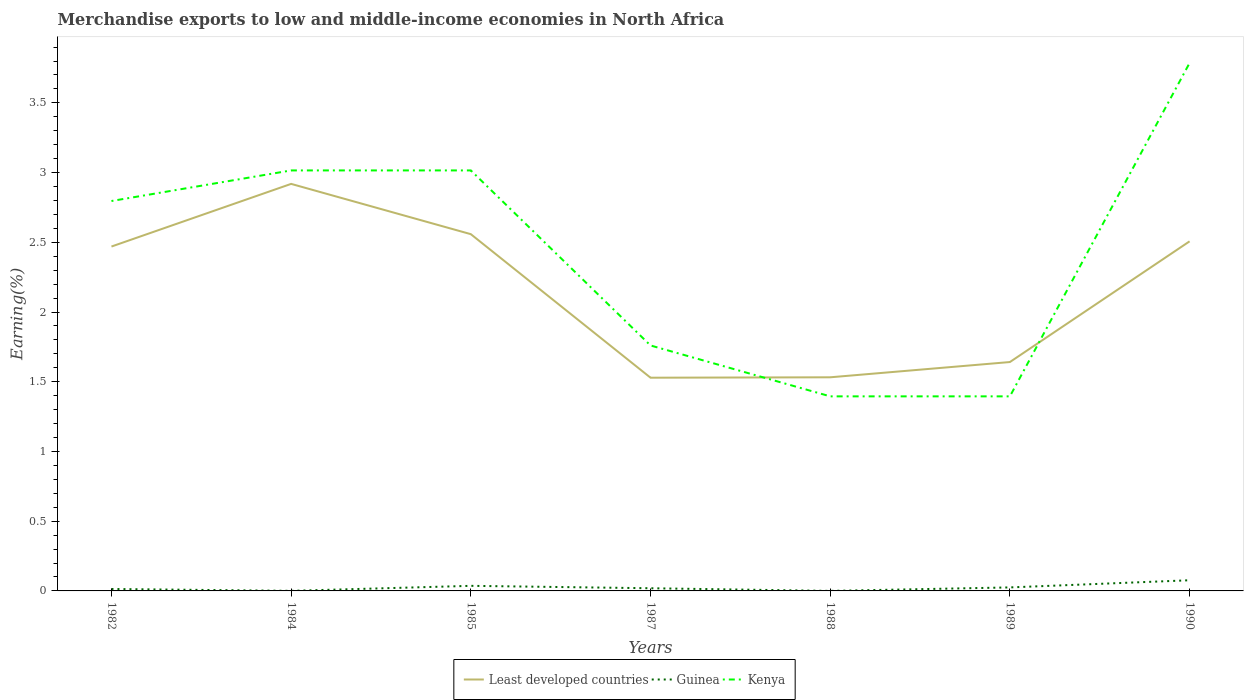How many different coloured lines are there?
Ensure brevity in your answer.  3. Does the line corresponding to Kenya intersect with the line corresponding to Guinea?
Provide a short and direct response. No. Is the number of lines equal to the number of legend labels?
Ensure brevity in your answer.  Yes. Across all years, what is the maximum percentage of amount earned from merchandise exports in Kenya?
Give a very brief answer. 1.4. What is the total percentage of amount earned from merchandise exports in Guinea in the graph?
Make the answer very short. -0.02. What is the difference between the highest and the second highest percentage of amount earned from merchandise exports in Guinea?
Offer a terse response. 0.08. How many lines are there?
Offer a terse response. 3. How many years are there in the graph?
Provide a succinct answer. 7. Does the graph contain grids?
Provide a succinct answer. No. How many legend labels are there?
Your answer should be very brief. 3. What is the title of the graph?
Ensure brevity in your answer.  Merchandise exports to low and middle-income economies in North Africa. What is the label or title of the Y-axis?
Make the answer very short. Earning(%). What is the Earning(%) of Least developed countries in 1982?
Give a very brief answer. 2.47. What is the Earning(%) in Guinea in 1982?
Offer a very short reply. 0.01. What is the Earning(%) in Kenya in 1982?
Keep it short and to the point. 2.8. What is the Earning(%) of Least developed countries in 1984?
Offer a terse response. 2.92. What is the Earning(%) in Guinea in 1984?
Offer a very short reply. 0. What is the Earning(%) of Kenya in 1984?
Ensure brevity in your answer.  3.02. What is the Earning(%) of Least developed countries in 1985?
Offer a terse response. 2.56. What is the Earning(%) of Guinea in 1985?
Your answer should be very brief. 0.04. What is the Earning(%) of Kenya in 1985?
Your response must be concise. 3.02. What is the Earning(%) in Least developed countries in 1987?
Make the answer very short. 1.53. What is the Earning(%) of Guinea in 1987?
Make the answer very short. 0.02. What is the Earning(%) in Kenya in 1987?
Your response must be concise. 1.76. What is the Earning(%) of Least developed countries in 1988?
Offer a very short reply. 1.53. What is the Earning(%) of Guinea in 1988?
Offer a terse response. 0. What is the Earning(%) of Kenya in 1988?
Your answer should be very brief. 1.4. What is the Earning(%) of Least developed countries in 1989?
Your answer should be compact. 1.64. What is the Earning(%) in Guinea in 1989?
Provide a short and direct response. 0.03. What is the Earning(%) of Kenya in 1989?
Provide a short and direct response. 1.4. What is the Earning(%) of Least developed countries in 1990?
Keep it short and to the point. 2.51. What is the Earning(%) in Guinea in 1990?
Offer a very short reply. 0.08. What is the Earning(%) in Kenya in 1990?
Provide a short and direct response. 3.79. Across all years, what is the maximum Earning(%) of Least developed countries?
Offer a very short reply. 2.92. Across all years, what is the maximum Earning(%) of Guinea?
Provide a short and direct response. 0.08. Across all years, what is the maximum Earning(%) in Kenya?
Provide a succinct answer. 3.79. Across all years, what is the minimum Earning(%) of Least developed countries?
Keep it short and to the point. 1.53. Across all years, what is the minimum Earning(%) in Guinea?
Ensure brevity in your answer.  0. Across all years, what is the minimum Earning(%) of Kenya?
Your answer should be compact. 1.4. What is the total Earning(%) of Least developed countries in the graph?
Your answer should be compact. 15.16. What is the total Earning(%) of Guinea in the graph?
Your answer should be very brief. 0.17. What is the total Earning(%) of Kenya in the graph?
Provide a short and direct response. 17.16. What is the difference between the Earning(%) of Least developed countries in 1982 and that in 1984?
Provide a succinct answer. -0.45. What is the difference between the Earning(%) of Guinea in 1982 and that in 1984?
Ensure brevity in your answer.  0.01. What is the difference between the Earning(%) in Kenya in 1982 and that in 1984?
Provide a short and direct response. -0.22. What is the difference between the Earning(%) in Least developed countries in 1982 and that in 1985?
Keep it short and to the point. -0.09. What is the difference between the Earning(%) in Guinea in 1982 and that in 1985?
Offer a terse response. -0.02. What is the difference between the Earning(%) in Kenya in 1982 and that in 1985?
Keep it short and to the point. -0.22. What is the difference between the Earning(%) of Least developed countries in 1982 and that in 1987?
Your answer should be very brief. 0.94. What is the difference between the Earning(%) of Guinea in 1982 and that in 1987?
Offer a terse response. -0.01. What is the difference between the Earning(%) in Kenya in 1982 and that in 1987?
Keep it short and to the point. 1.04. What is the difference between the Earning(%) in Least developed countries in 1982 and that in 1988?
Give a very brief answer. 0.94. What is the difference between the Earning(%) in Guinea in 1982 and that in 1988?
Your response must be concise. 0.01. What is the difference between the Earning(%) in Kenya in 1982 and that in 1988?
Your answer should be compact. 1.4. What is the difference between the Earning(%) in Least developed countries in 1982 and that in 1989?
Ensure brevity in your answer.  0.83. What is the difference between the Earning(%) of Guinea in 1982 and that in 1989?
Ensure brevity in your answer.  -0.01. What is the difference between the Earning(%) in Kenya in 1982 and that in 1989?
Provide a succinct answer. 1.4. What is the difference between the Earning(%) of Least developed countries in 1982 and that in 1990?
Keep it short and to the point. -0.04. What is the difference between the Earning(%) in Guinea in 1982 and that in 1990?
Provide a succinct answer. -0.06. What is the difference between the Earning(%) in Kenya in 1982 and that in 1990?
Make the answer very short. -0.99. What is the difference between the Earning(%) of Least developed countries in 1984 and that in 1985?
Keep it short and to the point. 0.36. What is the difference between the Earning(%) of Guinea in 1984 and that in 1985?
Ensure brevity in your answer.  -0.04. What is the difference between the Earning(%) of Kenya in 1984 and that in 1985?
Your answer should be compact. 0. What is the difference between the Earning(%) in Least developed countries in 1984 and that in 1987?
Your answer should be compact. 1.39. What is the difference between the Earning(%) of Guinea in 1984 and that in 1987?
Your response must be concise. -0.02. What is the difference between the Earning(%) in Kenya in 1984 and that in 1987?
Your answer should be compact. 1.26. What is the difference between the Earning(%) in Least developed countries in 1984 and that in 1988?
Ensure brevity in your answer.  1.39. What is the difference between the Earning(%) in Guinea in 1984 and that in 1988?
Keep it short and to the point. 0. What is the difference between the Earning(%) of Kenya in 1984 and that in 1988?
Your response must be concise. 1.62. What is the difference between the Earning(%) of Least developed countries in 1984 and that in 1989?
Offer a very short reply. 1.28. What is the difference between the Earning(%) in Guinea in 1984 and that in 1989?
Your answer should be very brief. -0.02. What is the difference between the Earning(%) of Kenya in 1984 and that in 1989?
Offer a terse response. 1.62. What is the difference between the Earning(%) in Least developed countries in 1984 and that in 1990?
Give a very brief answer. 0.41. What is the difference between the Earning(%) in Guinea in 1984 and that in 1990?
Offer a terse response. -0.08. What is the difference between the Earning(%) in Kenya in 1984 and that in 1990?
Give a very brief answer. -0.77. What is the difference between the Earning(%) of Least developed countries in 1985 and that in 1987?
Your answer should be very brief. 1.03. What is the difference between the Earning(%) in Guinea in 1985 and that in 1987?
Your response must be concise. 0.02. What is the difference between the Earning(%) in Kenya in 1985 and that in 1987?
Your answer should be very brief. 1.26. What is the difference between the Earning(%) in Least developed countries in 1985 and that in 1988?
Your answer should be compact. 1.03. What is the difference between the Earning(%) of Guinea in 1985 and that in 1988?
Give a very brief answer. 0.04. What is the difference between the Earning(%) in Kenya in 1985 and that in 1988?
Offer a very short reply. 1.62. What is the difference between the Earning(%) in Least developed countries in 1985 and that in 1989?
Your answer should be very brief. 0.92. What is the difference between the Earning(%) of Guinea in 1985 and that in 1989?
Keep it short and to the point. 0.01. What is the difference between the Earning(%) in Kenya in 1985 and that in 1989?
Give a very brief answer. 1.62. What is the difference between the Earning(%) in Least developed countries in 1985 and that in 1990?
Offer a very short reply. 0.05. What is the difference between the Earning(%) of Guinea in 1985 and that in 1990?
Give a very brief answer. -0.04. What is the difference between the Earning(%) of Kenya in 1985 and that in 1990?
Your response must be concise. -0.77. What is the difference between the Earning(%) of Least developed countries in 1987 and that in 1988?
Offer a terse response. -0. What is the difference between the Earning(%) in Guinea in 1987 and that in 1988?
Make the answer very short. 0.02. What is the difference between the Earning(%) of Kenya in 1987 and that in 1988?
Keep it short and to the point. 0.36. What is the difference between the Earning(%) in Least developed countries in 1987 and that in 1989?
Give a very brief answer. -0.11. What is the difference between the Earning(%) in Guinea in 1987 and that in 1989?
Give a very brief answer. -0.01. What is the difference between the Earning(%) of Kenya in 1987 and that in 1989?
Give a very brief answer. 0.36. What is the difference between the Earning(%) of Least developed countries in 1987 and that in 1990?
Make the answer very short. -0.98. What is the difference between the Earning(%) in Guinea in 1987 and that in 1990?
Offer a very short reply. -0.06. What is the difference between the Earning(%) of Kenya in 1987 and that in 1990?
Your answer should be compact. -2.03. What is the difference between the Earning(%) of Least developed countries in 1988 and that in 1989?
Offer a very short reply. -0.11. What is the difference between the Earning(%) in Guinea in 1988 and that in 1989?
Provide a short and direct response. -0.02. What is the difference between the Earning(%) of Least developed countries in 1988 and that in 1990?
Provide a succinct answer. -0.97. What is the difference between the Earning(%) in Guinea in 1988 and that in 1990?
Offer a very short reply. -0.08. What is the difference between the Earning(%) of Kenya in 1988 and that in 1990?
Your answer should be compact. -2.39. What is the difference between the Earning(%) in Least developed countries in 1989 and that in 1990?
Your answer should be compact. -0.87. What is the difference between the Earning(%) of Guinea in 1989 and that in 1990?
Provide a short and direct response. -0.05. What is the difference between the Earning(%) of Kenya in 1989 and that in 1990?
Your answer should be very brief. -2.39. What is the difference between the Earning(%) in Least developed countries in 1982 and the Earning(%) in Guinea in 1984?
Offer a very short reply. 2.47. What is the difference between the Earning(%) in Least developed countries in 1982 and the Earning(%) in Kenya in 1984?
Make the answer very short. -0.55. What is the difference between the Earning(%) of Guinea in 1982 and the Earning(%) of Kenya in 1984?
Your answer should be very brief. -3. What is the difference between the Earning(%) in Least developed countries in 1982 and the Earning(%) in Guinea in 1985?
Keep it short and to the point. 2.43. What is the difference between the Earning(%) in Least developed countries in 1982 and the Earning(%) in Kenya in 1985?
Ensure brevity in your answer.  -0.55. What is the difference between the Earning(%) of Guinea in 1982 and the Earning(%) of Kenya in 1985?
Make the answer very short. -3. What is the difference between the Earning(%) in Least developed countries in 1982 and the Earning(%) in Guinea in 1987?
Offer a very short reply. 2.45. What is the difference between the Earning(%) of Least developed countries in 1982 and the Earning(%) of Kenya in 1987?
Your response must be concise. 0.71. What is the difference between the Earning(%) of Guinea in 1982 and the Earning(%) of Kenya in 1987?
Your answer should be very brief. -1.75. What is the difference between the Earning(%) of Least developed countries in 1982 and the Earning(%) of Guinea in 1988?
Offer a terse response. 2.47. What is the difference between the Earning(%) of Least developed countries in 1982 and the Earning(%) of Kenya in 1988?
Keep it short and to the point. 1.07. What is the difference between the Earning(%) in Guinea in 1982 and the Earning(%) in Kenya in 1988?
Offer a very short reply. -1.38. What is the difference between the Earning(%) in Least developed countries in 1982 and the Earning(%) in Guinea in 1989?
Offer a very short reply. 2.44. What is the difference between the Earning(%) in Least developed countries in 1982 and the Earning(%) in Kenya in 1989?
Ensure brevity in your answer.  1.07. What is the difference between the Earning(%) of Guinea in 1982 and the Earning(%) of Kenya in 1989?
Offer a very short reply. -1.38. What is the difference between the Earning(%) of Least developed countries in 1982 and the Earning(%) of Guinea in 1990?
Keep it short and to the point. 2.39. What is the difference between the Earning(%) in Least developed countries in 1982 and the Earning(%) in Kenya in 1990?
Make the answer very short. -1.32. What is the difference between the Earning(%) of Guinea in 1982 and the Earning(%) of Kenya in 1990?
Provide a short and direct response. -3.77. What is the difference between the Earning(%) of Least developed countries in 1984 and the Earning(%) of Guinea in 1985?
Provide a succinct answer. 2.88. What is the difference between the Earning(%) of Least developed countries in 1984 and the Earning(%) of Kenya in 1985?
Your response must be concise. -0.1. What is the difference between the Earning(%) of Guinea in 1984 and the Earning(%) of Kenya in 1985?
Your response must be concise. -3.01. What is the difference between the Earning(%) in Least developed countries in 1984 and the Earning(%) in Guinea in 1987?
Provide a short and direct response. 2.9. What is the difference between the Earning(%) of Least developed countries in 1984 and the Earning(%) of Kenya in 1987?
Keep it short and to the point. 1.16. What is the difference between the Earning(%) in Guinea in 1984 and the Earning(%) in Kenya in 1987?
Offer a very short reply. -1.76. What is the difference between the Earning(%) in Least developed countries in 1984 and the Earning(%) in Guinea in 1988?
Offer a very short reply. 2.92. What is the difference between the Earning(%) of Least developed countries in 1984 and the Earning(%) of Kenya in 1988?
Your answer should be very brief. 1.52. What is the difference between the Earning(%) in Guinea in 1984 and the Earning(%) in Kenya in 1988?
Give a very brief answer. -1.39. What is the difference between the Earning(%) of Least developed countries in 1984 and the Earning(%) of Guinea in 1989?
Provide a succinct answer. 2.89. What is the difference between the Earning(%) in Least developed countries in 1984 and the Earning(%) in Kenya in 1989?
Your answer should be very brief. 1.52. What is the difference between the Earning(%) in Guinea in 1984 and the Earning(%) in Kenya in 1989?
Provide a succinct answer. -1.39. What is the difference between the Earning(%) in Least developed countries in 1984 and the Earning(%) in Guinea in 1990?
Ensure brevity in your answer.  2.84. What is the difference between the Earning(%) in Least developed countries in 1984 and the Earning(%) in Kenya in 1990?
Your response must be concise. -0.87. What is the difference between the Earning(%) of Guinea in 1984 and the Earning(%) of Kenya in 1990?
Make the answer very short. -3.79. What is the difference between the Earning(%) of Least developed countries in 1985 and the Earning(%) of Guinea in 1987?
Your answer should be very brief. 2.54. What is the difference between the Earning(%) in Least developed countries in 1985 and the Earning(%) in Kenya in 1987?
Ensure brevity in your answer.  0.8. What is the difference between the Earning(%) in Guinea in 1985 and the Earning(%) in Kenya in 1987?
Offer a terse response. -1.72. What is the difference between the Earning(%) of Least developed countries in 1985 and the Earning(%) of Guinea in 1988?
Keep it short and to the point. 2.56. What is the difference between the Earning(%) of Least developed countries in 1985 and the Earning(%) of Kenya in 1988?
Ensure brevity in your answer.  1.16. What is the difference between the Earning(%) in Guinea in 1985 and the Earning(%) in Kenya in 1988?
Provide a succinct answer. -1.36. What is the difference between the Earning(%) in Least developed countries in 1985 and the Earning(%) in Guinea in 1989?
Your answer should be very brief. 2.53. What is the difference between the Earning(%) in Least developed countries in 1985 and the Earning(%) in Kenya in 1989?
Give a very brief answer. 1.16. What is the difference between the Earning(%) of Guinea in 1985 and the Earning(%) of Kenya in 1989?
Provide a short and direct response. -1.36. What is the difference between the Earning(%) in Least developed countries in 1985 and the Earning(%) in Guinea in 1990?
Make the answer very short. 2.48. What is the difference between the Earning(%) of Least developed countries in 1985 and the Earning(%) of Kenya in 1990?
Your response must be concise. -1.23. What is the difference between the Earning(%) in Guinea in 1985 and the Earning(%) in Kenya in 1990?
Your response must be concise. -3.75. What is the difference between the Earning(%) in Least developed countries in 1987 and the Earning(%) in Guinea in 1988?
Your answer should be compact. 1.53. What is the difference between the Earning(%) of Least developed countries in 1987 and the Earning(%) of Kenya in 1988?
Your answer should be compact. 0.13. What is the difference between the Earning(%) of Guinea in 1987 and the Earning(%) of Kenya in 1988?
Offer a very short reply. -1.38. What is the difference between the Earning(%) in Least developed countries in 1987 and the Earning(%) in Guinea in 1989?
Make the answer very short. 1.5. What is the difference between the Earning(%) of Least developed countries in 1987 and the Earning(%) of Kenya in 1989?
Provide a short and direct response. 0.13. What is the difference between the Earning(%) in Guinea in 1987 and the Earning(%) in Kenya in 1989?
Your answer should be compact. -1.38. What is the difference between the Earning(%) of Least developed countries in 1987 and the Earning(%) of Guinea in 1990?
Your answer should be compact. 1.45. What is the difference between the Earning(%) of Least developed countries in 1987 and the Earning(%) of Kenya in 1990?
Offer a terse response. -2.26. What is the difference between the Earning(%) in Guinea in 1987 and the Earning(%) in Kenya in 1990?
Keep it short and to the point. -3.77. What is the difference between the Earning(%) in Least developed countries in 1988 and the Earning(%) in Guinea in 1989?
Offer a very short reply. 1.51. What is the difference between the Earning(%) of Least developed countries in 1988 and the Earning(%) of Kenya in 1989?
Ensure brevity in your answer.  0.14. What is the difference between the Earning(%) in Guinea in 1988 and the Earning(%) in Kenya in 1989?
Your answer should be compact. -1.4. What is the difference between the Earning(%) in Least developed countries in 1988 and the Earning(%) in Guinea in 1990?
Offer a very short reply. 1.46. What is the difference between the Earning(%) in Least developed countries in 1988 and the Earning(%) in Kenya in 1990?
Provide a succinct answer. -2.25. What is the difference between the Earning(%) in Guinea in 1988 and the Earning(%) in Kenya in 1990?
Ensure brevity in your answer.  -3.79. What is the difference between the Earning(%) in Least developed countries in 1989 and the Earning(%) in Guinea in 1990?
Provide a short and direct response. 1.56. What is the difference between the Earning(%) of Least developed countries in 1989 and the Earning(%) of Kenya in 1990?
Provide a short and direct response. -2.14. What is the difference between the Earning(%) of Guinea in 1989 and the Earning(%) of Kenya in 1990?
Make the answer very short. -3.76. What is the average Earning(%) in Least developed countries per year?
Make the answer very short. 2.17. What is the average Earning(%) of Guinea per year?
Offer a very short reply. 0.02. What is the average Earning(%) in Kenya per year?
Your answer should be compact. 2.45. In the year 1982, what is the difference between the Earning(%) in Least developed countries and Earning(%) in Guinea?
Offer a terse response. 2.46. In the year 1982, what is the difference between the Earning(%) of Least developed countries and Earning(%) of Kenya?
Make the answer very short. -0.33. In the year 1982, what is the difference between the Earning(%) of Guinea and Earning(%) of Kenya?
Ensure brevity in your answer.  -2.78. In the year 1984, what is the difference between the Earning(%) in Least developed countries and Earning(%) in Guinea?
Make the answer very short. 2.92. In the year 1984, what is the difference between the Earning(%) in Least developed countries and Earning(%) in Kenya?
Your answer should be very brief. -0.1. In the year 1984, what is the difference between the Earning(%) of Guinea and Earning(%) of Kenya?
Offer a very short reply. -3.01. In the year 1985, what is the difference between the Earning(%) of Least developed countries and Earning(%) of Guinea?
Your response must be concise. 2.52. In the year 1985, what is the difference between the Earning(%) of Least developed countries and Earning(%) of Kenya?
Give a very brief answer. -0.46. In the year 1985, what is the difference between the Earning(%) in Guinea and Earning(%) in Kenya?
Your answer should be compact. -2.98. In the year 1987, what is the difference between the Earning(%) in Least developed countries and Earning(%) in Guinea?
Give a very brief answer. 1.51. In the year 1987, what is the difference between the Earning(%) in Least developed countries and Earning(%) in Kenya?
Provide a succinct answer. -0.23. In the year 1987, what is the difference between the Earning(%) of Guinea and Earning(%) of Kenya?
Your response must be concise. -1.74. In the year 1988, what is the difference between the Earning(%) in Least developed countries and Earning(%) in Guinea?
Your answer should be very brief. 1.53. In the year 1988, what is the difference between the Earning(%) of Least developed countries and Earning(%) of Kenya?
Your answer should be compact. 0.14. In the year 1988, what is the difference between the Earning(%) in Guinea and Earning(%) in Kenya?
Your answer should be very brief. -1.4. In the year 1989, what is the difference between the Earning(%) of Least developed countries and Earning(%) of Guinea?
Offer a terse response. 1.62. In the year 1989, what is the difference between the Earning(%) of Least developed countries and Earning(%) of Kenya?
Provide a succinct answer. 0.25. In the year 1989, what is the difference between the Earning(%) in Guinea and Earning(%) in Kenya?
Your answer should be very brief. -1.37. In the year 1990, what is the difference between the Earning(%) of Least developed countries and Earning(%) of Guinea?
Provide a short and direct response. 2.43. In the year 1990, what is the difference between the Earning(%) of Least developed countries and Earning(%) of Kenya?
Give a very brief answer. -1.28. In the year 1990, what is the difference between the Earning(%) in Guinea and Earning(%) in Kenya?
Keep it short and to the point. -3.71. What is the ratio of the Earning(%) in Least developed countries in 1982 to that in 1984?
Your response must be concise. 0.85. What is the ratio of the Earning(%) in Guinea in 1982 to that in 1984?
Give a very brief answer. 23.64. What is the ratio of the Earning(%) in Kenya in 1982 to that in 1984?
Offer a very short reply. 0.93. What is the ratio of the Earning(%) in Least developed countries in 1982 to that in 1985?
Give a very brief answer. 0.97. What is the ratio of the Earning(%) in Guinea in 1982 to that in 1985?
Give a very brief answer. 0.38. What is the ratio of the Earning(%) in Kenya in 1982 to that in 1985?
Make the answer very short. 0.93. What is the ratio of the Earning(%) in Least developed countries in 1982 to that in 1987?
Ensure brevity in your answer.  1.62. What is the ratio of the Earning(%) in Guinea in 1982 to that in 1987?
Offer a terse response. 0.73. What is the ratio of the Earning(%) in Kenya in 1982 to that in 1987?
Your answer should be compact. 1.59. What is the ratio of the Earning(%) in Least developed countries in 1982 to that in 1988?
Your answer should be compact. 1.61. What is the ratio of the Earning(%) of Guinea in 1982 to that in 1988?
Ensure brevity in your answer.  71.57. What is the ratio of the Earning(%) in Kenya in 1982 to that in 1988?
Make the answer very short. 2. What is the ratio of the Earning(%) in Least developed countries in 1982 to that in 1989?
Ensure brevity in your answer.  1.5. What is the ratio of the Earning(%) in Guinea in 1982 to that in 1989?
Give a very brief answer. 0.55. What is the ratio of the Earning(%) of Kenya in 1982 to that in 1989?
Offer a terse response. 2. What is the ratio of the Earning(%) of Least developed countries in 1982 to that in 1990?
Keep it short and to the point. 0.99. What is the ratio of the Earning(%) of Guinea in 1982 to that in 1990?
Provide a succinct answer. 0.18. What is the ratio of the Earning(%) in Kenya in 1982 to that in 1990?
Your response must be concise. 0.74. What is the ratio of the Earning(%) in Least developed countries in 1984 to that in 1985?
Provide a succinct answer. 1.14. What is the ratio of the Earning(%) in Guinea in 1984 to that in 1985?
Ensure brevity in your answer.  0.02. What is the ratio of the Earning(%) of Kenya in 1984 to that in 1985?
Offer a terse response. 1. What is the ratio of the Earning(%) of Least developed countries in 1984 to that in 1987?
Make the answer very short. 1.91. What is the ratio of the Earning(%) in Guinea in 1984 to that in 1987?
Offer a terse response. 0.03. What is the ratio of the Earning(%) in Kenya in 1984 to that in 1987?
Give a very brief answer. 1.71. What is the ratio of the Earning(%) of Least developed countries in 1984 to that in 1988?
Keep it short and to the point. 1.91. What is the ratio of the Earning(%) in Guinea in 1984 to that in 1988?
Offer a very short reply. 3.03. What is the ratio of the Earning(%) in Kenya in 1984 to that in 1988?
Your response must be concise. 2.16. What is the ratio of the Earning(%) of Least developed countries in 1984 to that in 1989?
Your response must be concise. 1.78. What is the ratio of the Earning(%) of Guinea in 1984 to that in 1989?
Your answer should be compact. 0.02. What is the ratio of the Earning(%) in Kenya in 1984 to that in 1989?
Offer a very short reply. 2.16. What is the ratio of the Earning(%) in Least developed countries in 1984 to that in 1990?
Ensure brevity in your answer.  1.16. What is the ratio of the Earning(%) of Guinea in 1984 to that in 1990?
Ensure brevity in your answer.  0.01. What is the ratio of the Earning(%) in Kenya in 1984 to that in 1990?
Provide a short and direct response. 0.8. What is the ratio of the Earning(%) of Least developed countries in 1985 to that in 1987?
Your response must be concise. 1.67. What is the ratio of the Earning(%) in Guinea in 1985 to that in 1987?
Provide a succinct answer. 1.9. What is the ratio of the Earning(%) of Kenya in 1985 to that in 1987?
Provide a succinct answer. 1.71. What is the ratio of the Earning(%) in Least developed countries in 1985 to that in 1988?
Ensure brevity in your answer.  1.67. What is the ratio of the Earning(%) in Guinea in 1985 to that in 1988?
Provide a succinct answer. 187.1. What is the ratio of the Earning(%) in Kenya in 1985 to that in 1988?
Your response must be concise. 2.16. What is the ratio of the Earning(%) of Least developed countries in 1985 to that in 1989?
Keep it short and to the point. 1.56. What is the ratio of the Earning(%) of Guinea in 1985 to that in 1989?
Your answer should be very brief. 1.45. What is the ratio of the Earning(%) of Kenya in 1985 to that in 1989?
Offer a terse response. 2.16. What is the ratio of the Earning(%) of Least developed countries in 1985 to that in 1990?
Provide a short and direct response. 1.02. What is the ratio of the Earning(%) of Guinea in 1985 to that in 1990?
Offer a very short reply. 0.48. What is the ratio of the Earning(%) of Kenya in 1985 to that in 1990?
Give a very brief answer. 0.8. What is the ratio of the Earning(%) in Guinea in 1987 to that in 1988?
Your answer should be compact. 98.59. What is the ratio of the Earning(%) in Kenya in 1987 to that in 1988?
Offer a terse response. 1.26. What is the ratio of the Earning(%) of Least developed countries in 1987 to that in 1989?
Make the answer very short. 0.93. What is the ratio of the Earning(%) in Guinea in 1987 to that in 1989?
Make the answer very short. 0.76. What is the ratio of the Earning(%) in Kenya in 1987 to that in 1989?
Offer a very short reply. 1.26. What is the ratio of the Earning(%) of Least developed countries in 1987 to that in 1990?
Offer a very short reply. 0.61. What is the ratio of the Earning(%) of Guinea in 1987 to that in 1990?
Make the answer very short. 0.25. What is the ratio of the Earning(%) in Kenya in 1987 to that in 1990?
Your answer should be compact. 0.46. What is the ratio of the Earning(%) of Guinea in 1988 to that in 1989?
Make the answer very short. 0.01. What is the ratio of the Earning(%) in Least developed countries in 1988 to that in 1990?
Offer a terse response. 0.61. What is the ratio of the Earning(%) in Guinea in 1988 to that in 1990?
Make the answer very short. 0. What is the ratio of the Earning(%) of Kenya in 1988 to that in 1990?
Offer a very short reply. 0.37. What is the ratio of the Earning(%) in Least developed countries in 1989 to that in 1990?
Offer a terse response. 0.65. What is the ratio of the Earning(%) in Guinea in 1989 to that in 1990?
Provide a succinct answer. 0.33. What is the ratio of the Earning(%) of Kenya in 1989 to that in 1990?
Provide a short and direct response. 0.37. What is the difference between the highest and the second highest Earning(%) of Least developed countries?
Make the answer very short. 0.36. What is the difference between the highest and the second highest Earning(%) of Guinea?
Your response must be concise. 0.04. What is the difference between the highest and the second highest Earning(%) in Kenya?
Provide a short and direct response. 0.77. What is the difference between the highest and the lowest Earning(%) of Least developed countries?
Offer a very short reply. 1.39. What is the difference between the highest and the lowest Earning(%) of Guinea?
Keep it short and to the point. 0.08. What is the difference between the highest and the lowest Earning(%) in Kenya?
Your answer should be compact. 2.39. 